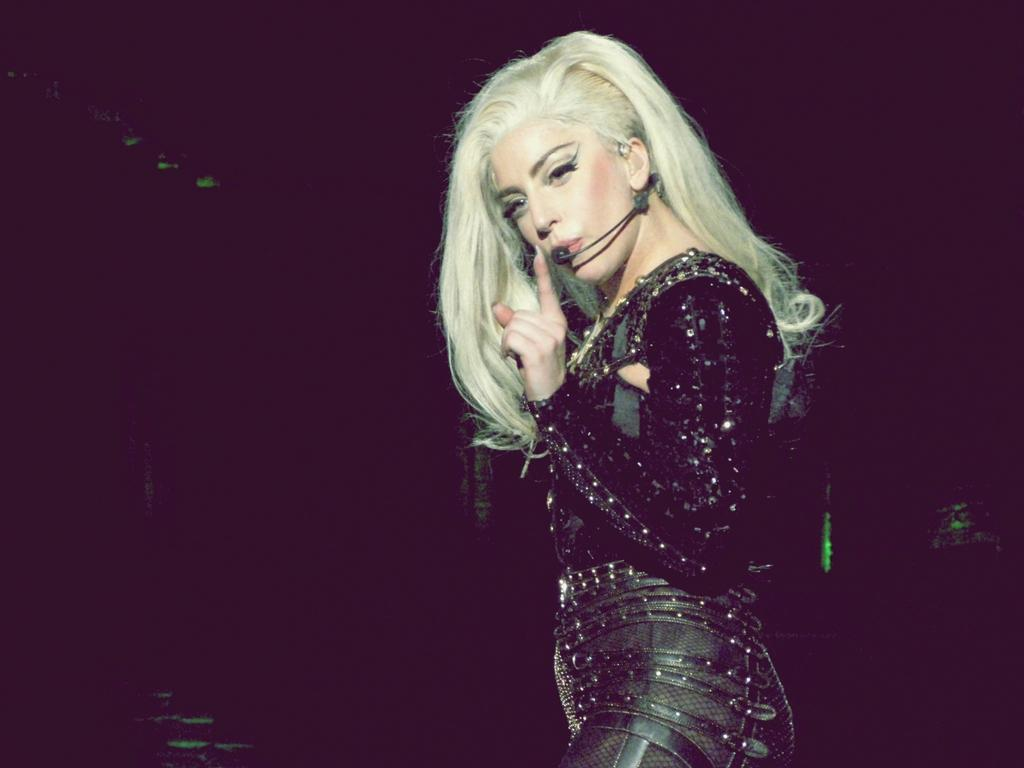What is the main subject of the image? The main subject of the image is a woman standing. Can you describe the background of the image? The background of the image is dark. What type of tool is the woman using to measure the distance in the image? There is no tool or indication of measuring distance present in the image. Can you see any police officers in the image? There is no mention or presence of police officers in the image. What is the woman wearing on her wrist in the image? There is no specific detail about the woman's wrist visible in the image. 